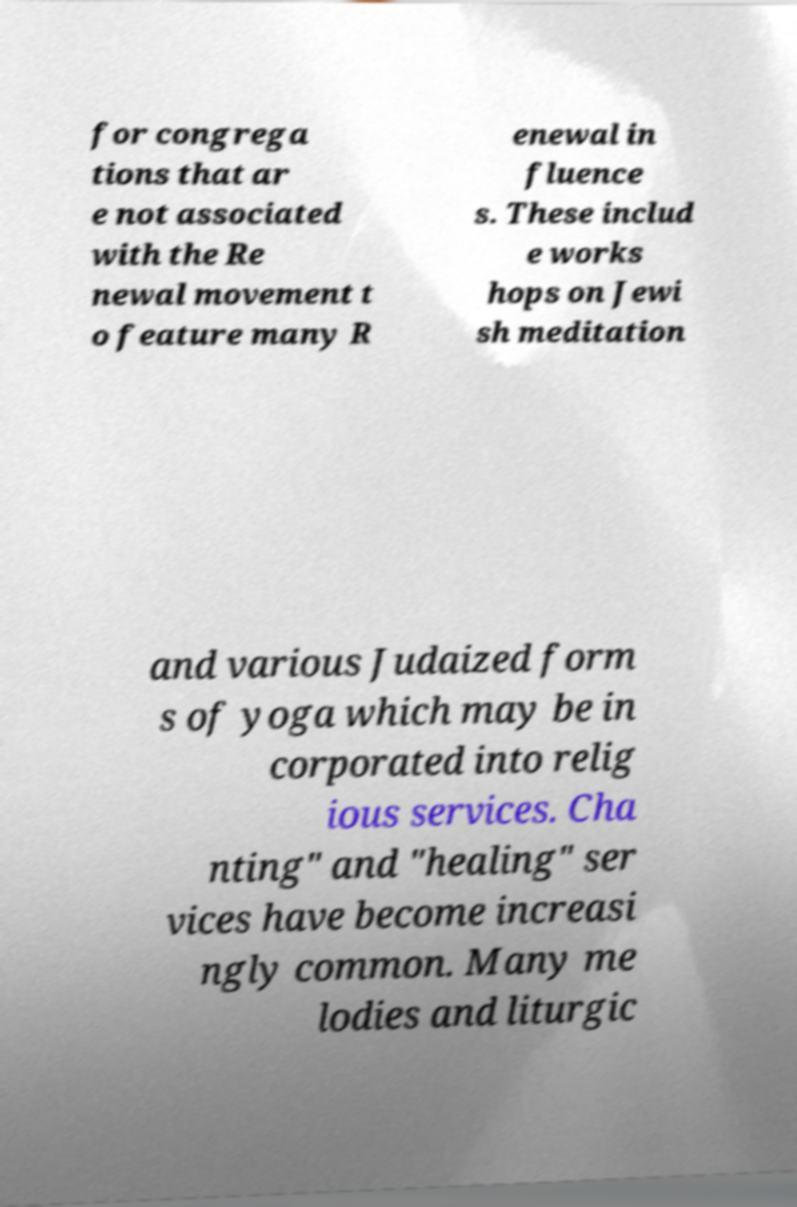Can you accurately transcribe the text from the provided image for me? for congrega tions that ar e not associated with the Re newal movement t o feature many R enewal in fluence s. These includ e works hops on Jewi sh meditation and various Judaized form s of yoga which may be in corporated into relig ious services. Cha nting" and "healing" ser vices have become increasi ngly common. Many me lodies and liturgic 